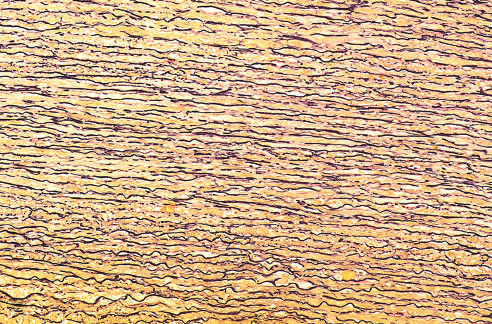did the majority of tissue macrophages show the regular layered pattern of elastic tissue?
Answer the question using a single word or phrase. No 